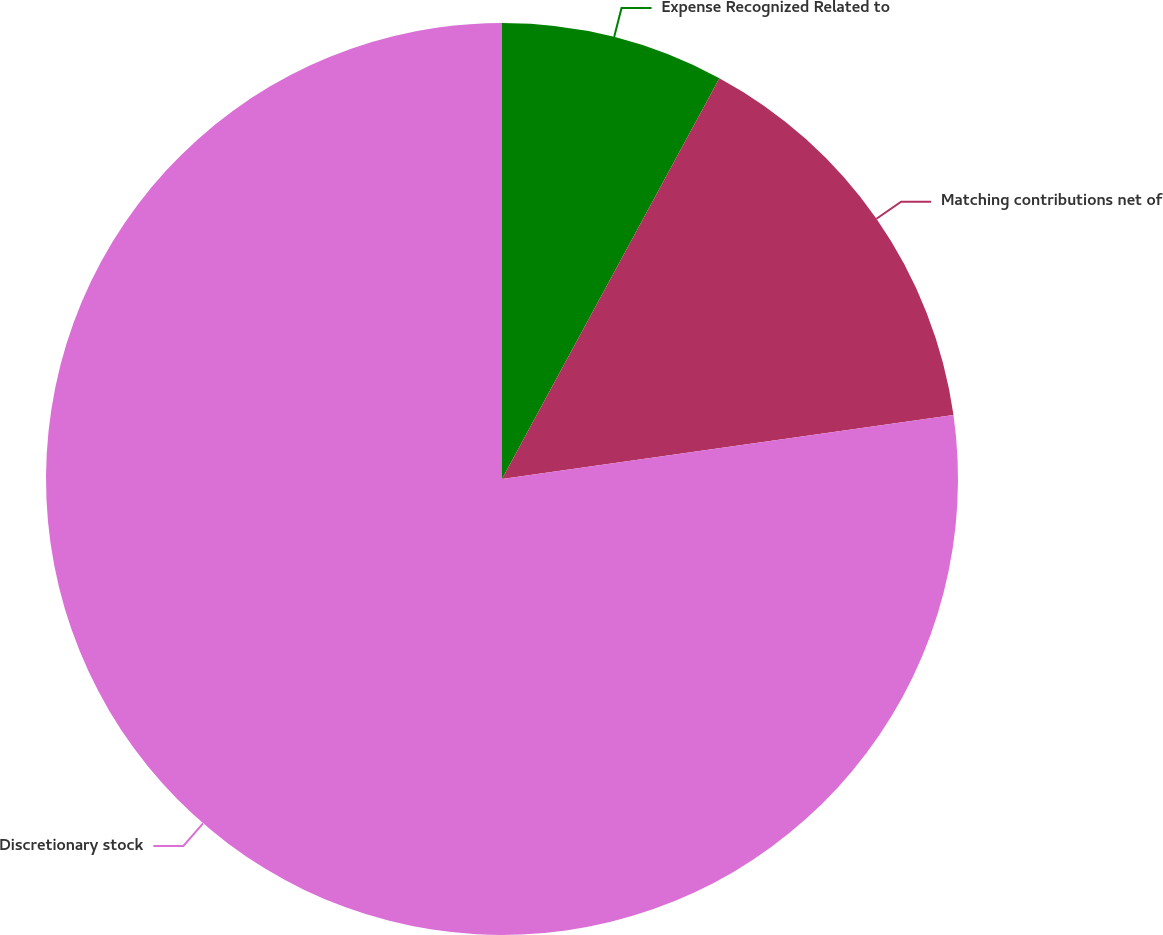<chart> <loc_0><loc_0><loc_500><loc_500><pie_chart><fcel>Expense Recognized Related to<fcel>Matching contributions net of<fcel>Discretionary stock<nl><fcel>7.91%<fcel>14.85%<fcel>77.24%<nl></chart> 